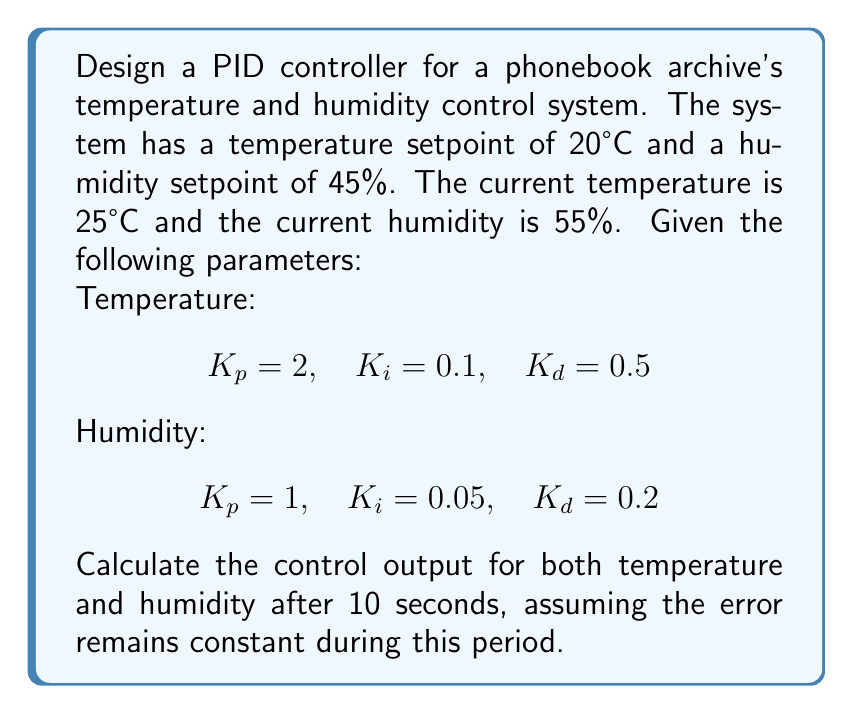Provide a solution to this math problem. To solve this problem, we need to use the PID controller equation for both temperature and humidity:

$$ u(t) = K_p e(t) + K_i \int_0^t e(\tau) d\tau + K_d \frac{de(t)}{dt} $$

Where:
$u(t)$ is the control output
$e(t)$ is the error (setpoint - current value)
$K_p$, $K_i$, and $K_d$ are the proportional, integral, and derivative gains, respectively

1. Calculate the error for temperature and humidity:
   Temperature error: $e_T = 20°C - 25°C = -5°C$
   Humidity error: $e_H = 45\% - 55\% = -10\%$

2. For temperature control:
   $K_p = 2$, $K_i = 0.1$, $K_d = 0.5$
   
   Proportional term: $K_p e_T = 2 \times (-5) = -10$
   
   Integral term: $K_i \int_0^t e_T(\tau) d\tau = 0.1 \times (-5) \times 10 = -5$
   
   Derivative term: Since the error is constant, $\frac{de_T(t)}{dt} = 0$, so this term is 0.
   
   Temperature control output: $u_T = -10 - 5 + 0 = -15$

3. For humidity control:
   $K_p = 1$, $K_i = 0.05$, $K_d = 0.2$
   
   Proportional term: $K_p e_H = 1 \times (-10) = -10$
   
   Integral term: $K_i \int_0^t e_H(\tau) d\tau = 0.05 \times (-10) \times 10 = -5$
   
   Derivative term: Since the error is constant, $\frac{de_H(t)}{dt} = 0$, so this term is 0.
   
   Humidity control output: $u_H = -10 - 5 + 0 = -15$
Answer: Temperature control output: $u_T = -15$
Humidity control output: $u_H = -15$ 